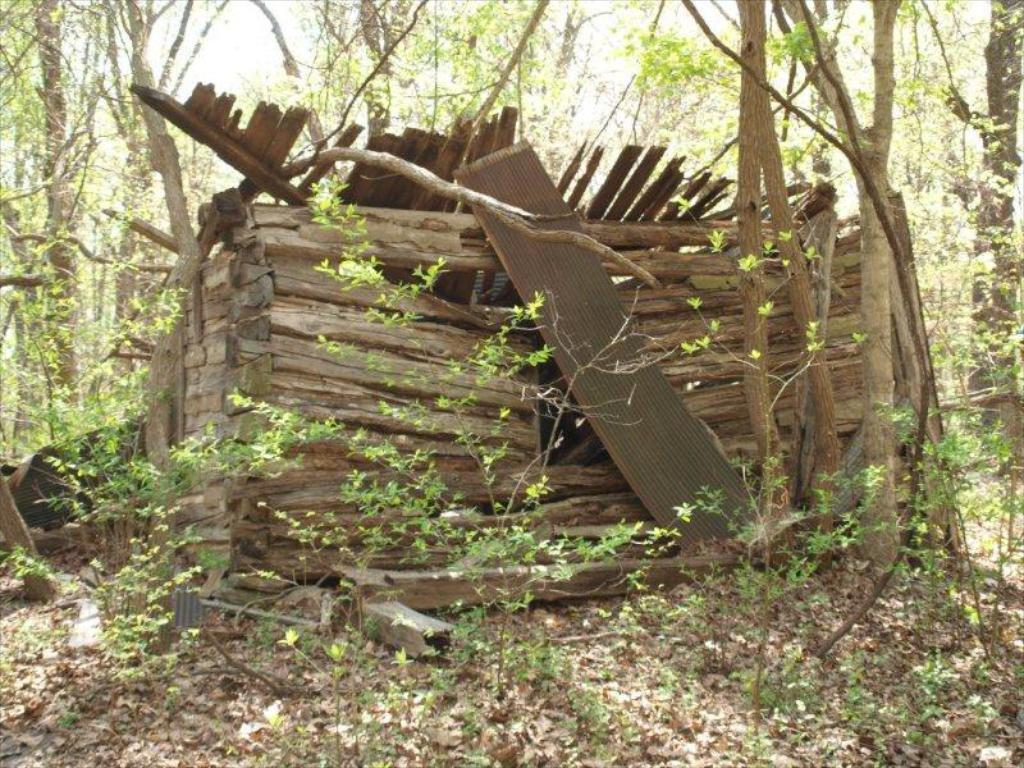What is located in the center of the image? There is a group of wood logs, a metal sheet, and plants in the center of the image. Can you describe the plants in the center of the image? The plants in the center of the image are not specified, but they are present alongside the wood logs and metal sheet. What can be seen in the background of the image? There is a group of trees and the sky visible in the background of the image. How many goldfish are swimming in the metal sheet in the image? There are no goldfish present in the image; it features a group of wood logs, a metal sheet, and plants in the center, along with trees and the sky in the background. What type of seed can be seen growing on the wood logs in the image? There is no mention of seeds in the image; it only features wood logs, a metal sheet, plants, trees, and the sky. 